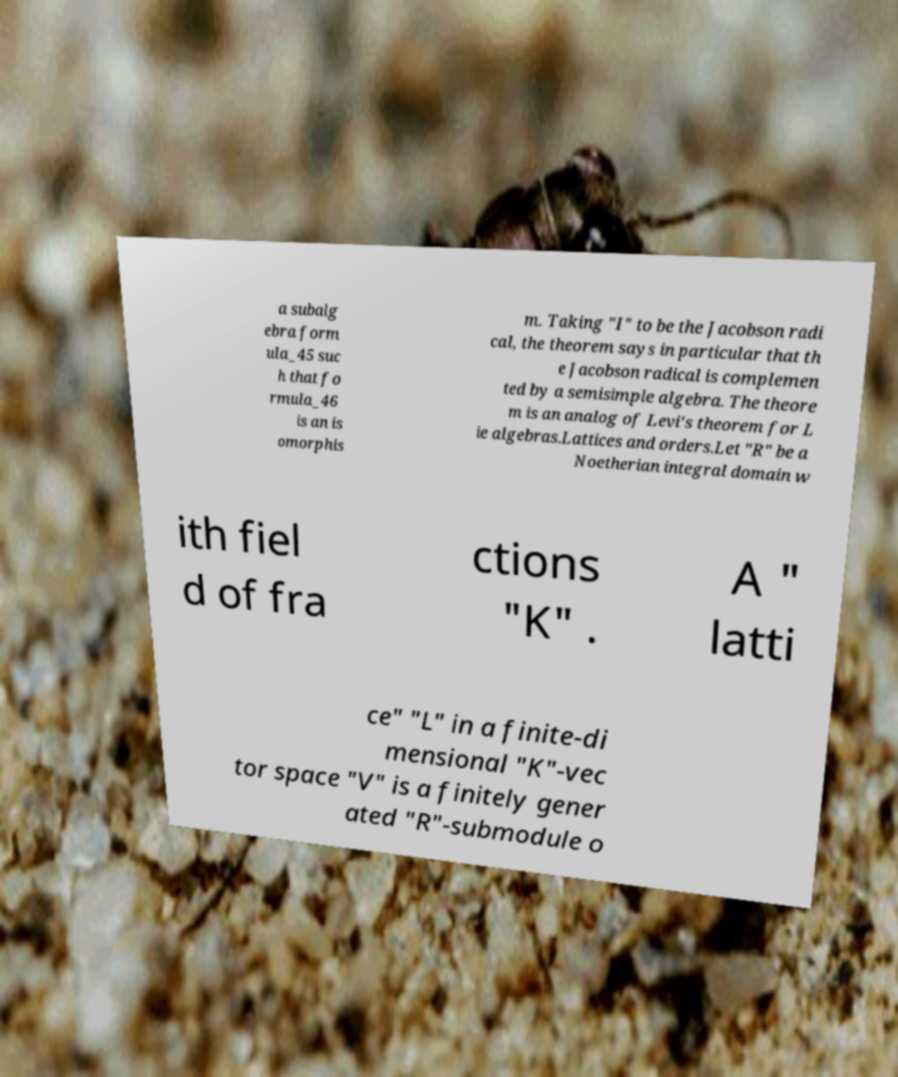There's text embedded in this image that I need extracted. Can you transcribe it verbatim? a subalg ebra form ula_45 suc h that fo rmula_46 is an is omorphis m. Taking "I" to be the Jacobson radi cal, the theorem says in particular that th e Jacobson radical is complemen ted by a semisimple algebra. The theore m is an analog of Levi's theorem for L ie algebras.Lattices and orders.Let "R" be a Noetherian integral domain w ith fiel d of fra ctions "K" . A " latti ce" "L" in a finite-di mensional "K"-vec tor space "V" is a finitely gener ated "R"-submodule o 